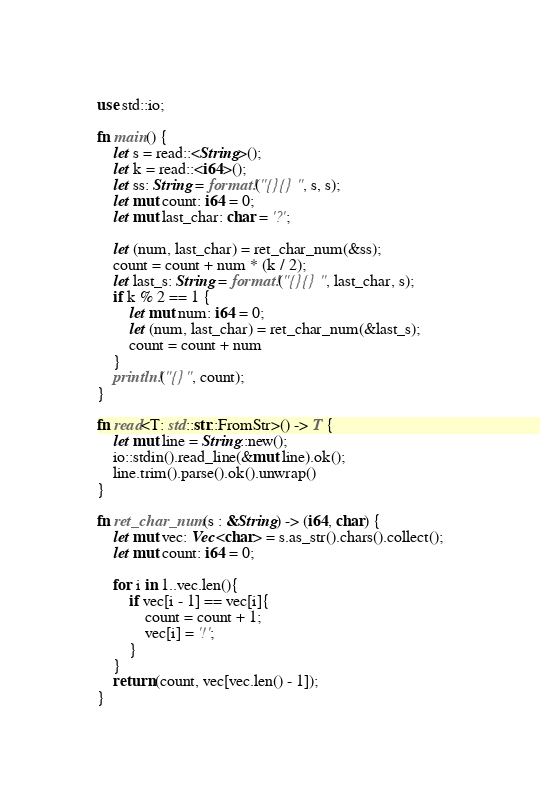<code> <loc_0><loc_0><loc_500><loc_500><_Rust_>use std::io;

fn main() {
	let s = read::<String>();
	let k = read::<i64>();
	let ss: String = format!("{}{}", s, s);
	let mut count: i64 = 0;
	let mut last_char: char = '?';

	let (num, last_char) = ret_char_num(&ss);
	count = count + num * (k / 2);
	let last_s: String = format!("{}{}", last_char, s);
	if k % 2 == 1 {
		let mut num: i64 = 0;
		let (num, last_char) = ret_char_num(&last_s);
		count = count + num
	}
	println!("{}", count);
}

fn read<T: std::str::FromStr>() -> T {
	let mut line = String::new();
	io::stdin().read_line(&mut line).ok();
	line.trim().parse().ok().unwrap()
}

fn ret_char_num(s : &String) -> (i64, char) {
	let mut vec: Vec<char> = s.as_str().chars().collect();
	let mut count: i64 = 0;

	for i in 1..vec.len(){
		if vec[i - 1] == vec[i]{
			count = count + 1;
			vec[i] = '!';
		}
	}
	return (count, vec[vec.len() - 1]);
}</code> 